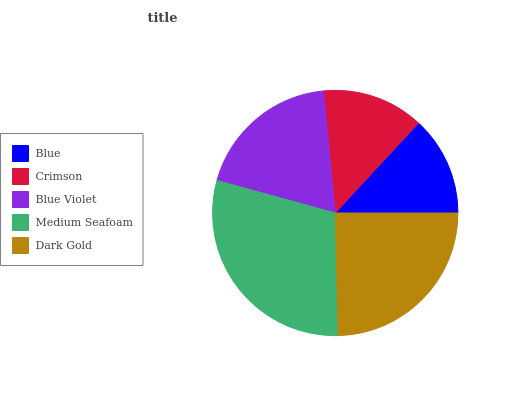Is Blue the minimum?
Answer yes or no. Yes. Is Medium Seafoam the maximum?
Answer yes or no. Yes. Is Crimson the minimum?
Answer yes or no. No. Is Crimson the maximum?
Answer yes or no. No. Is Crimson greater than Blue?
Answer yes or no. Yes. Is Blue less than Crimson?
Answer yes or no. Yes. Is Blue greater than Crimson?
Answer yes or no. No. Is Crimson less than Blue?
Answer yes or no. No. Is Blue Violet the high median?
Answer yes or no. Yes. Is Blue Violet the low median?
Answer yes or no. Yes. Is Medium Seafoam the high median?
Answer yes or no. No. Is Dark Gold the low median?
Answer yes or no. No. 